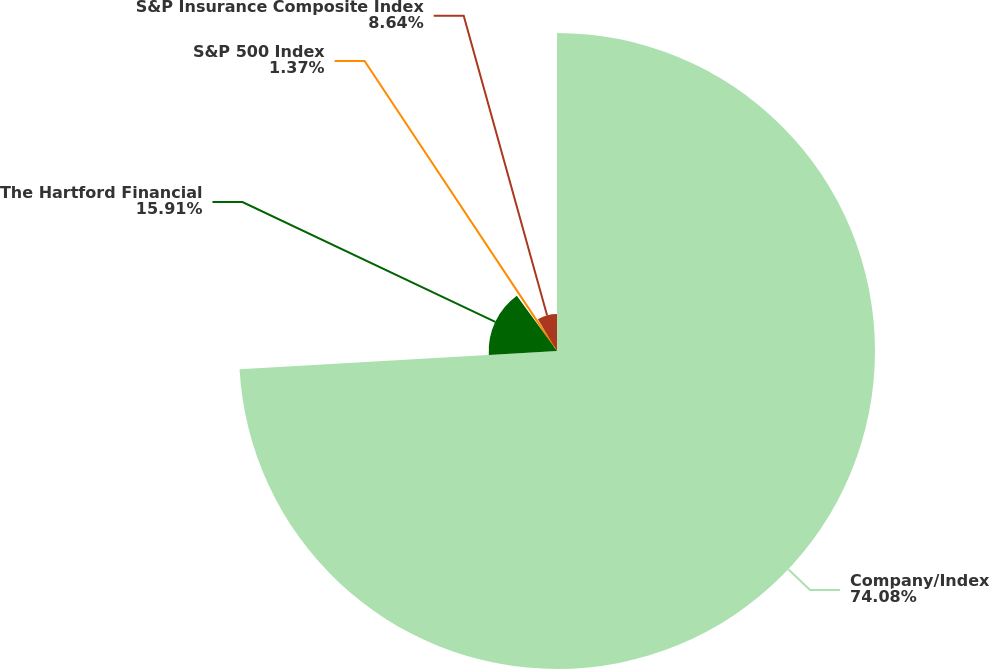Convert chart. <chart><loc_0><loc_0><loc_500><loc_500><pie_chart><fcel>Company/Index<fcel>The Hartford Financial<fcel>S&P 500 Index<fcel>S&P Insurance Composite Index<nl><fcel>74.09%<fcel>15.91%<fcel>1.37%<fcel>8.64%<nl></chart> 